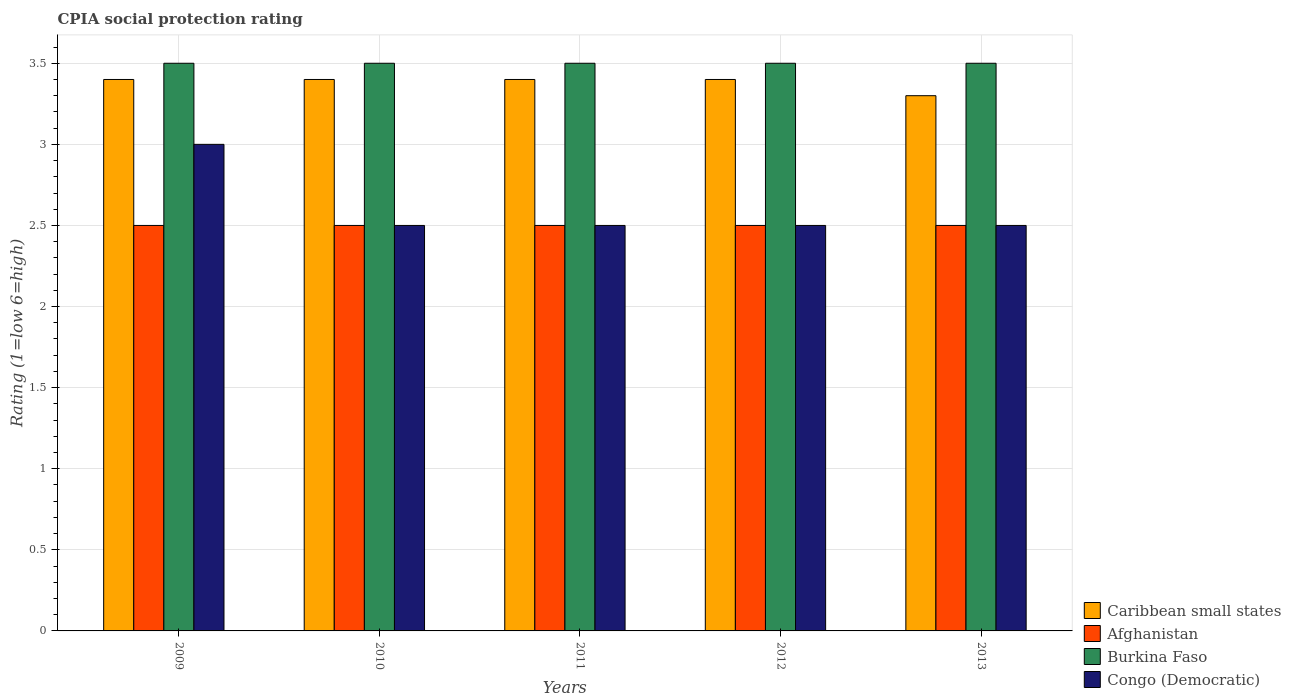How many different coloured bars are there?
Your response must be concise. 4. How many groups of bars are there?
Ensure brevity in your answer.  5. Are the number of bars on each tick of the X-axis equal?
Your response must be concise. Yes. How many bars are there on the 3rd tick from the right?
Keep it short and to the point. 4. In how many cases, is the number of bars for a given year not equal to the number of legend labels?
Give a very brief answer. 0. What is the CPIA rating in Burkina Faso in 2010?
Your response must be concise. 3.5. In which year was the CPIA rating in Burkina Faso maximum?
Make the answer very short. 2009. In which year was the CPIA rating in Burkina Faso minimum?
Provide a short and direct response. 2009. What is the total CPIA rating in Congo (Democratic) in the graph?
Provide a short and direct response. 13. What is the difference between the CPIA rating in Congo (Democratic) in 2012 and that in 2013?
Your answer should be very brief. 0. What is the difference between the CPIA rating in Caribbean small states in 2010 and the CPIA rating in Congo (Democratic) in 2009?
Provide a short and direct response. 0.4. In the year 2009, what is the difference between the CPIA rating in Caribbean small states and CPIA rating in Burkina Faso?
Offer a very short reply. -0.1. What is the difference between the highest and the second highest CPIA rating in Afghanistan?
Offer a terse response. 0. What is the difference between the highest and the lowest CPIA rating in Caribbean small states?
Give a very brief answer. 0.1. In how many years, is the CPIA rating in Caribbean small states greater than the average CPIA rating in Caribbean small states taken over all years?
Your answer should be compact. 4. What does the 4th bar from the left in 2012 represents?
Give a very brief answer. Congo (Democratic). What does the 3rd bar from the right in 2010 represents?
Provide a short and direct response. Afghanistan. How many bars are there?
Your answer should be compact. 20. Are the values on the major ticks of Y-axis written in scientific E-notation?
Give a very brief answer. No. Does the graph contain any zero values?
Offer a terse response. No. Where does the legend appear in the graph?
Make the answer very short. Bottom right. How are the legend labels stacked?
Provide a succinct answer. Vertical. What is the title of the graph?
Provide a succinct answer. CPIA social protection rating. Does "Isle of Man" appear as one of the legend labels in the graph?
Your answer should be very brief. No. What is the label or title of the X-axis?
Provide a succinct answer. Years. What is the Rating (1=low 6=high) of Afghanistan in 2009?
Make the answer very short. 2.5. What is the Rating (1=low 6=high) in Burkina Faso in 2009?
Offer a terse response. 3.5. What is the Rating (1=low 6=high) in Caribbean small states in 2010?
Your response must be concise. 3.4. What is the Rating (1=low 6=high) in Afghanistan in 2010?
Ensure brevity in your answer.  2.5. What is the Rating (1=low 6=high) of Caribbean small states in 2011?
Keep it short and to the point. 3.4. What is the Rating (1=low 6=high) of Caribbean small states in 2012?
Keep it short and to the point. 3.4. What is the Rating (1=low 6=high) in Afghanistan in 2012?
Your answer should be compact. 2.5. What is the Rating (1=low 6=high) of Caribbean small states in 2013?
Provide a succinct answer. 3.3. What is the Rating (1=low 6=high) of Burkina Faso in 2013?
Give a very brief answer. 3.5. Across all years, what is the maximum Rating (1=low 6=high) of Congo (Democratic)?
Keep it short and to the point. 3. Across all years, what is the minimum Rating (1=low 6=high) of Afghanistan?
Your answer should be very brief. 2.5. What is the total Rating (1=low 6=high) of Caribbean small states in the graph?
Offer a very short reply. 16.9. What is the total Rating (1=low 6=high) of Burkina Faso in the graph?
Offer a terse response. 17.5. What is the difference between the Rating (1=low 6=high) in Burkina Faso in 2009 and that in 2011?
Give a very brief answer. 0. What is the difference between the Rating (1=low 6=high) in Afghanistan in 2009 and that in 2012?
Provide a succinct answer. 0. What is the difference between the Rating (1=low 6=high) in Congo (Democratic) in 2009 and that in 2012?
Ensure brevity in your answer.  0.5. What is the difference between the Rating (1=low 6=high) of Caribbean small states in 2009 and that in 2013?
Give a very brief answer. 0.1. What is the difference between the Rating (1=low 6=high) of Afghanistan in 2009 and that in 2013?
Ensure brevity in your answer.  0. What is the difference between the Rating (1=low 6=high) in Burkina Faso in 2009 and that in 2013?
Offer a terse response. 0. What is the difference between the Rating (1=low 6=high) in Afghanistan in 2010 and that in 2011?
Your response must be concise. 0. What is the difference between the Rating (1=low 6=high) of Burkina Faso in 2010 and that in 2011?
Keep it short and to the point. 0. What is the difference between the Rating (1=low 6=high) in Caribbean small states in 2010 and that in 2012?
Keep it short and to the point. 0. What is the difference between the Rating (1=low 6=high) of Caribbean small states in 2010 and that in 2013?
Your answer should be compact. 0.1. What is the difference between the Rating (1=low 6=high) in Afghanistan in 2010 and that in 2013?
Offer a very short reply. 0. What is the difference between the Rating (1=low 6=high) of Burkina Faso in 2010 and that in 2013?
Make the answer very short. 0. What is the difference between the Rating (1=low 6=high) in Congo (Democratic) in 2011 and that in 2012?
Ensure brevity in your answer.  0. What is the difference between the Rating (1=low 6=high) of Afghanistan in 2011 and that in 2013?
Provide a succinct answer. 0. What is the difference between the Rating (1=low 6=high) in Burkina Faso in 2011 and that in 2013?
Offer a terse response. 0. What is the difference between the Rating (1=low 6=high) of Congo (Democratic) in 2011 and that in 2013?
Keep it short and to the point. 0. What is the difference between the Rating (1=low 6=high) in Afghanistan in 2012 and that in 2013?
Provide a succinct answer. 0. What is the difference between the Rating (1=low 6=high) of Burkina Faso in 2012 and that in 2013?
Offer a very short reply. 0. What is the difference between the Rating (1=low 6=high) in Afghanistan in 2009 and the Rating (1=low 6=high) in Burkina Faso in 2010?
Your answer should be very brief. -1. What is the difference between the Rating (1=low 6=high) in Afghanistan in 2009 and the Rating (1=low 6=high) in Congo (Democratic) in 2010?
Offer a terse response. 0. What is the difference between the Rating (1=low 6=high) in Burkina Faso in 2009 and the Rating (1=low 6=high) in Congo (Democratic) in 2010?
Offer a very short reply. 1. What is the difference between the Rating (1=low 6=high) of Caribbean small states in 2009 and the Rating (1=low 6=high) of Congo (Democratic) in 2011?
Give a very brief answer. 0.9. What is the difference between the Rating (1=low 6=high) in Afghanistan in 2009 and the Rating (1=low 6=high) in Congo (Democratic) in 2011?
Make the answer very short. 0. What is the difference between the Rating (1=low 6=high) of Burkina Faso in 2009 and the Rating (1=low 6=high) of Congo (Democratic) in 2011?
Keep it short and to the point. 1. What is the difference between the Rating (1=low 6=high) in Caribbean small states in 2009 and the Rating (1=low 6=high) in Afghanistan in 2012?
Give a very brief answer. 0.9. What is the difference between the Rating (1=low 6=high) in Caribbean small states in 2009 and the Rating (1=low 6=high) in Burkina Faso in 2012?
Give a very brief answer. -0.1. What is the difference between the Rating (1=low 6=high) of Afghanistan in 2009 and the Rating (1=low 6=high) of Congo (Democratic) in 2012?
Give a very brief answer. 0. What is the difference between the Rating (1=low 6=high) of Caribbean small states in 2009 and the Rating (1=low 6=high) of Afghanistan in 2013?
Your answer should be very brief. 0.9. What is the difference between the Rating (1=low 6=high) of Caribbean small states in 2009 and the Rating (1=low 6=high) of Burkina Faso in 2013?
Offer a terse response. -0.1. What is the difference between the Rating (1=low 6=high) in Caribbean small states in 2009 and the Rating (1=low 6=high) in Congo (Democratic) in 2013?
Offer a very short reply. 0.9. What is the difference between the Rating (1=low 6=high) of Afghanistan in 2009 and the Rating (1=low 6=high) of Congo (Democratic) in 2013?
Give a very brief answer. 0. What is the difference between the Rating (1=low 6=high) in Caribbean small states in 2010 and the Rating (1=low 6=high) in Afghanistan in 2011?
Your response must be concise. 0.9. What is the difference between the Rating (1=low 6=high) of Caribbean small states in 2010 and the Rating (1=low 6=high) of Burkina Faso in 2011?
Ensure brevity in your answer.  -0.1. What is the difference between the Rating (1=low 6=high) of Afghanistan in 2010 and the Rating (1=low 6=high) of Burkina Faso in 2011?
Keep it short and to the point. -1. What is the difference between the Rating (1=low 6=high) in Afghanistan in 2010 and the Rating (1=low 6=high) in Congo (Democratic) in 2011?
Offer a terse response. 0. What is the difference between the Rating (1=low 6=high) in Caribbean small states in 2010 and the Rating (1=low 6=high) in Burkina Faso in 2012?
Provide a succinct answer. -0.1. What is the difference between the Rating (1=low 6=high) of Afghanistan in 2010 and the Rating (1=low 6=high) of Burkina Faso in 2012?
Keep it short and to the point. -1. What is the difference between the Rating (1=low 6=high) of Afghanistan in 2010 and the Rating (1=low 6=high) of Congo (Democratic) in 2012?
Provide a succinct answer. 0. What is the difference between the Rating (1=low 6=high) of Caribbean small states in 2010 and the Rating (1=low 6=high) of Congo (Democratic) in 2013?
Ensure brevity in your answer.  0.9. What is the difference between the Rating (1=low 6=high) in Afghanistan in 2010 and the Rating (1=low 6=high) in Congo (Democratic) in 2013?
Provide a succinct answer. 0. What is the difference between the Rating (1=low 6=high) of Burkina Faso in 2010 and the Rating (1=low 6=high) of Congo (Democratic) in 2013?
Offer a terse response. 1. What is the difference between the Rating (1=low 6=high) of Caribbean small states in 2011 and the Rating (1=low 6=high) of Afghanistan in 2012?
Keep it short and to the point. 0.9. What is the difference between the Rating (1=low 6=high) in Caribbean small states in 2011 and the Rating (1=low 6=high) in Burkina Faso in 2012?
Your answer should be very brief. -0.1. What is the difference between the Rating (1=low 6=high) of Caribbean small states in 2011 and the Rating (1=low 6=high) of Congo (Democratic) in 2012?
Your answer should be compact. 0.9. What is the difference between the Rating (1=low 6=high) of Afghanistan in 2011 and the Rating (1=low 6=high) of Burkina Faso in 2012?
Provide a succinct answer. -1. What is the difference between the Rating (1=low 6=high) of Afghanistan in 2011 and the Rating (1=low 6=high) of Congo (Democratic) in 2012?
Give a very brief answer. 0. What is the difference between the Rating (1=low 6=high) in Burkina Faso in 2011 and the Rating (1=low 6=high) in Congo (Democratic) in 2012?
Offer a very short reply. 1. What is the difference between the Rating (1=low 6=high) in Caribbean small states in 2011 and the Rating (1=low 6=high) in Burkina Faso in 2013?
Your answer should be very brief. -0.1. What is the difference between the Rating (1=low 6=high) in Caribbean small states in 2011 and the Rating (1=low 6=high) in Congo (Democratic) in 2013?
Offer a very short reply. 0.9. What is the difference between the Rating (1=low 6=high) in Afghanistan in 2012 and the Rating (1=low 6=high) in Congo (Democratic) in 2013?
Provide a succinct answer. 0. What is the average Rating (1=low 6=high) in Caribbean small states per year?
Make the answer very short. 3.38. What is the average Rating (1=low 6=high) in Afghanistan per year?
Offer a terse response. 2.5. What is the average Rating (1=low 6=high) in Congo (Democratic) per year?
Your response must be concise. 2.6. In the year 2009, what is the difference between the Rating (1=low 6=high) in Caribbean small states and Rating (1=low 6=high) in Afghanistan?
Ensure brevity in your answer.  0.9. In the year 2009, what is the difference between the Rating (1=low 6=high) in Caribbean small states and Rating (1=low 6=high) in Congo (Democratic)?
Your answer should be very brief. 0.4. In the year 2010, what is the difference between the Rating (1=low 6=high) of Caribbean small states and Rating (1=low 6=high) of Burkina Faso?
Make the answer very short. -0.1. In the year 2010, what is the difference between the Rating (1=low 6=high) of Burkina Faso and Rating (1=low 6=high) of Congo (Democratic)?
Your response must be concise. 1. In the year 2011, what is the difference between the Rating (1=low 6=high) of Caribbean small states and Rating (1=low 6=high) of Burkina Faso?
Provide a short and direct response. -0.1. In the year 2011, what is the difference between the Rating (1=low 6=high) of Caribbean small states and Rating (1=low 6=high) of Congo (Democratic)?
Make the answer very short. 0.9. In the year 2011, what is the difference between the Rating (1=low 6=high) of Afghanistan and Rating (1=low 6=high) of Congo (Democratic)?
Offer a terse response. 0. In the year 2012, what is the difference between the Rating (1=low 6=high) of Caribbean small states and Rating (1=low 6=high) of Congo (Democratic)?
Ensure brevity in your answer.  0.9. In the year 2012, what is the difference between the Rating (1=low 6=high) in Afghanistan and Rating (1=low 6=high) in Burkina Faso?
Your answer should be compact. -1. In the year 2013, what is the difference between the Rating (1=low 6=high) of Caribbean small states and Rating (1=low 6=high) of Afghanistan?
Provide a succinct answer. 0.8. In the year 2013, what is the difference between the Rating (1=low 6=high) of Caribbean small states and Rating (1=low 6=high) of Congo (Democratic)?
Provide a short and direct response. 0.8. In the year 2013, what is the difference between the Rating (1=low 6=high) of Afghanistan and Rating (1=low 6=high) of Burkina Faso?
Offer a terse response. -1. In the year 2013, what is the difference between the Rating (1=low 6=high) of Afghanistan and Rating (1=low 6=high) of Congo (Democratic)?
Ensure brevity in your answer.  0. In the year 2013, what is the difference between the Rating (1=low 6=high) in Burkina Faso and Rating (1=low 6=high) in Congo (Democratic)?
Your response must be concise. 1. What is the ratio of the Rating (1=low 6=high) in Caribbean small states in 2009 to that in 2010?
Make the answer very short. 1. What is the ratio of the Rating (1=low 6=high) of Congo (Democratic) in 2009 to that in 2010?
Your response must be concise. 1.2. What is the ratio of the Rating (1=low 6=high) in Burkina Faso in 2009 to that in 2011?
Provide a succinct answer. 1. What is the ratio of the Rating (1=low 6=high) in Congo (Democratic) in 2009 to that in 2011?
Your answer should be compact. 1.2. What is the ratio of the Rating (1=low 6=high) in Afghanistan in 2009 to that in 2012?
Provide a short and direct response. 1. What is the ratio of the Rating (1=low 6=high) of Burkina Faso in 2009 to that in 2012?
Give a very brief answer. 1. What is the ratio of the Rating (1=low 6=high) of Caribbean small states in 2009 to that in 2013?
Keep it short and to the point. 1.03. What is the ratio of the Rating (1=low 6=high) in Afghanistan in 2009 to that in 2013?
Ensure brevity in your answer.  1. What is the ratio of the Rating (1=low 6=high) of Afghanistan in 2010 to that in 2011?
Provide a succinct answer. 1. What is the ratio of the Rating (1=low 6=high) of Caribbean small states in 2010 to that in 2012?
Provide a short and direct response. 1. What is the ratio of the Rating (1=low 6=high) in Afghanistan in 2010 to that in 2012?
Your answer should be very brief. 1. What is the ratio of the Rating (1=low 6=high) in Burkina Faso in 2010 to that in 2012?
Keep it short and to the point. 1. What is the ratio of the Rating (1=low 6=high) of Congo (Democratic) in 2010 to that in 2012?
Your answer should be compact. 1. What is the ratio of the Rating (1=low 6=high) of Caribbean small states in 2010 to that in 2013?
Provide a succinct answer. 1.03. What is the ratio of the Rating (1=low 6=high) of Burkina Faso in 2010 to that in 2013?
Give a very brief answer. 1. What is the ratio of the Rating (1=low 6=high) in Congo (Democratic) in 2010 to that in 2013?
Provide a succinct answer. 1. What is the ratio of the Rating (1=low 6=high) of Afghanistan in 2011 to that in 2012?
Provide a short and direct response. 1. What is the ratio of the Rating (1=low 6=high) in Congo (Democratic) in 2011 to that in 2012?
Your response must be concise. 1. What is the ratio of the Rating (1=low 6=high) of Caribbean small states in 2011 to that in 2013?
Offer a very short reply. 1.03. What is the ratio of the Rating (1=low 6=high) of Afghanistan in 2011 to that in 2013?
Make the answer very short. 1. What is the ratio of the Rating (1=low 6=high) in Caribbean small states in 2012 to that in 2013?
Provide a succinct answer. 1.03. What is the ratio of the Rating (1=low 6=high) of Congo (Democratic) in 2012 to that in 2013?
Offer a terse response. 1. What is the difference between the highest and the second highest Rating (1=low 6=high) in Caribbean small states?
Keep it short and to the point. 0. What is the difference between the highest and the second highest Rating (1=low 6=high) of Burkina Faso?
Provide a short and direct response. 0. What is the difference between the highest and the lowest Rating (1=low 6=high) in Caribbean small states?
Make the answer very short. 0.1. What is the difference between the highest and the lowest Rating (1=low 6=high) in Afghanistan?
Your answer should be compact. 0. What is the difference between the highest and the lowest Rating (1=low 6=high) of Burkina Faso?
Offer a very short reply. 0. What is the difference between the highest and the lowest Rating (1=low 6=high) in Congo (Democratic)?
Your answer should be very brief. 0.5. 